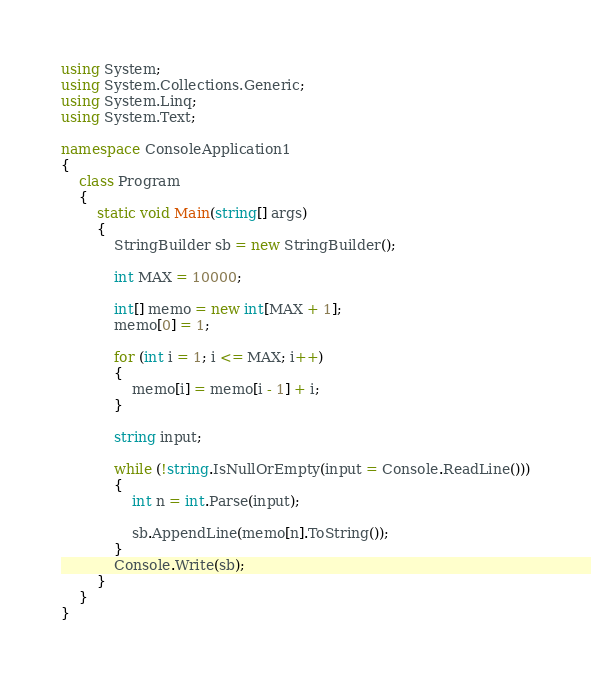<code> <loc_0><loc_0><loc_500><loc_500><_C#_>using System;
using System.Collections.Generic;
using System.Linq;
using System.Text;

namespace ConsoleApplication1
{
    class Program
    {
        static void Main(string[] args)
        {
            StringBuilder sb = new StringBuilder();

            int MAX = 10000;

            int[] memo = new int[MAX + 1];
            memo[0] = 1;

            for (int i = 1; i <= MAX; i++)
            {
                memo[i] = memo[i - 1] + i;
            }

            string input;

            while (!string.IsNullOrEmpty(input = Console.ReadLine()))
            {
                int n = int.Parse(input);

                sb.AppendLine(memo[n].ToString());
            }
            Console.Write(sb);
        }
    }
}</code> 